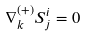Convert formula to latex. <formula><loc_0><loc_0><loc_500><loc_500>\nabla _ { k } ^ { ( + ) } S _ { j } ^ { i } = 0</formula> 